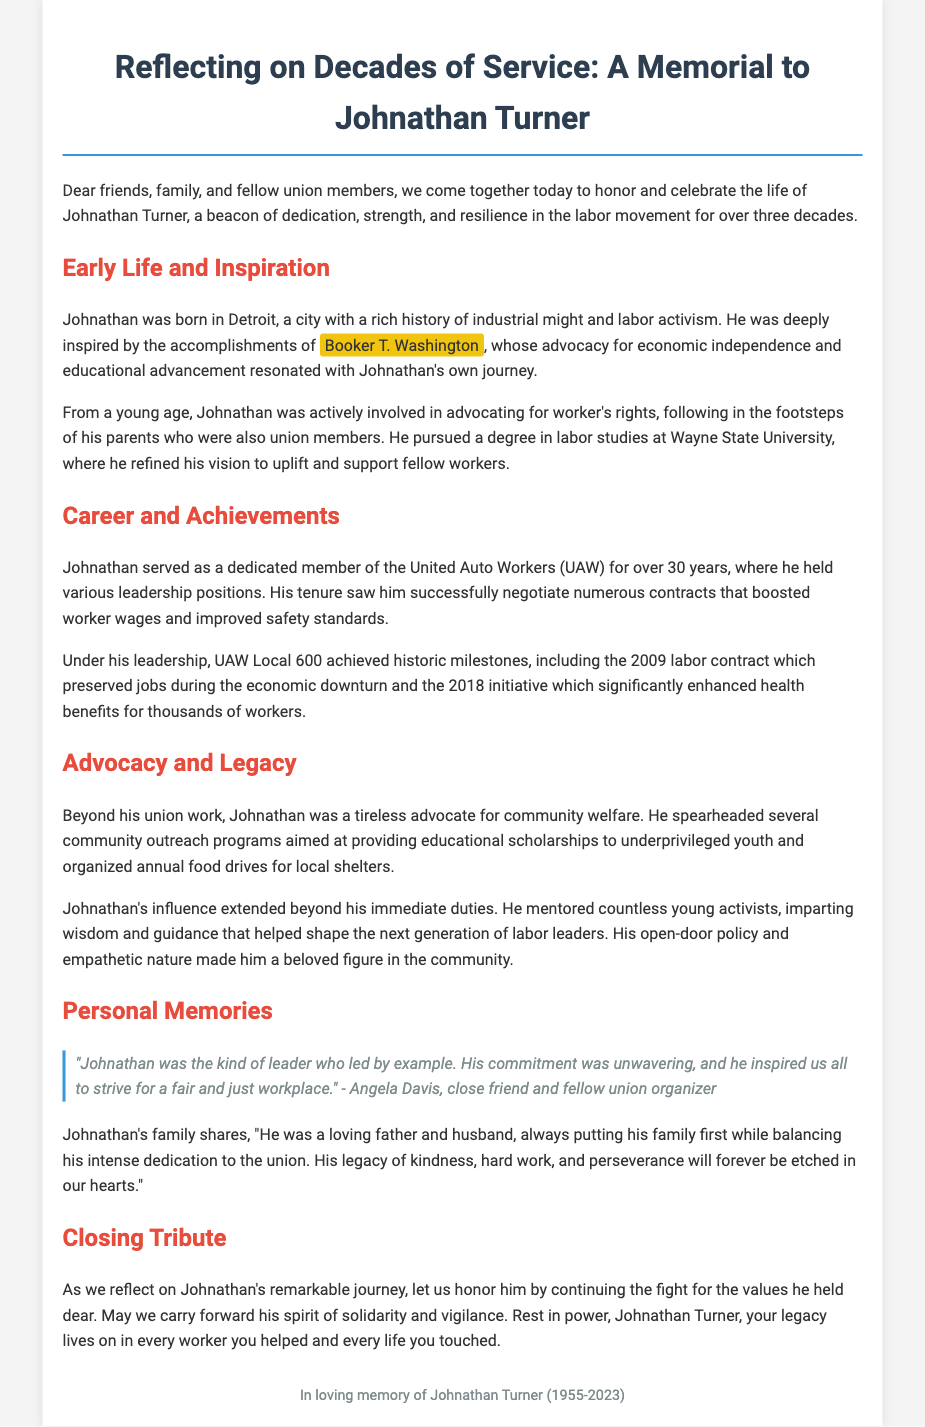What city was Johnathan Turner born in? The document states that Johnathan was born in Detroit.
Answer: Detroit How many years did Johnathan serve in the UAW? Johnathan served as a dedicated member of the UAW for over 30 years.
Answer: 30 years What impactful achievement is noted from the 2009 labor contract? The 2009 labor contract preserved jobs during the economic downturn.
Answer: Preserved jobs Who mentioned Johnathan's leadership in the quote provided? Angela Davis is the one who mentioned Johnathan's leadership in the quote.
Answer: Angela Davis What did Johnathan's family say about his priorities? They stated that he always put his family first while balancing his dedication to the union.
Answer: Family first What kind of community programs did Johnathan spearhead? Johnathan spearheaded community outreach programs for educational scholarships and food drives.
Answer: Scholarships and food drives What was Johnathan's commitment towards young activists? He mentored countless young activists, shaping the next generation of labor leaders.
Answer: Mentoring What phrase refers to Johnathan's legacy in the closing tribute? The phrase "your legacy lives on" is used to refer to Johnathan's impact.
Answer: Your legacy lives on 